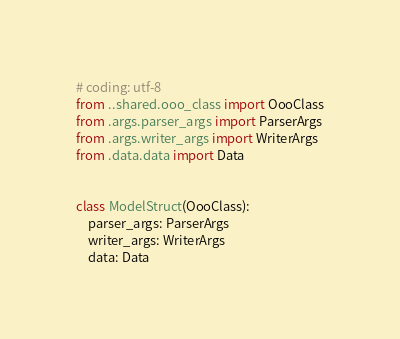Convert code to text. <code><loc_0><loc_0><loc_500><loc_500><_Python_># coding: utf-8
from ..shared.ooo_class import OooClass
from .args.parser_args import ParserArgs
from .args.writer_args import WriterArgs
from .data.data import Data


class ModelStruct(OooClass):
    parser_args: ParserArgs
    writer_args: WriterArgs
    data: Data
</code> 